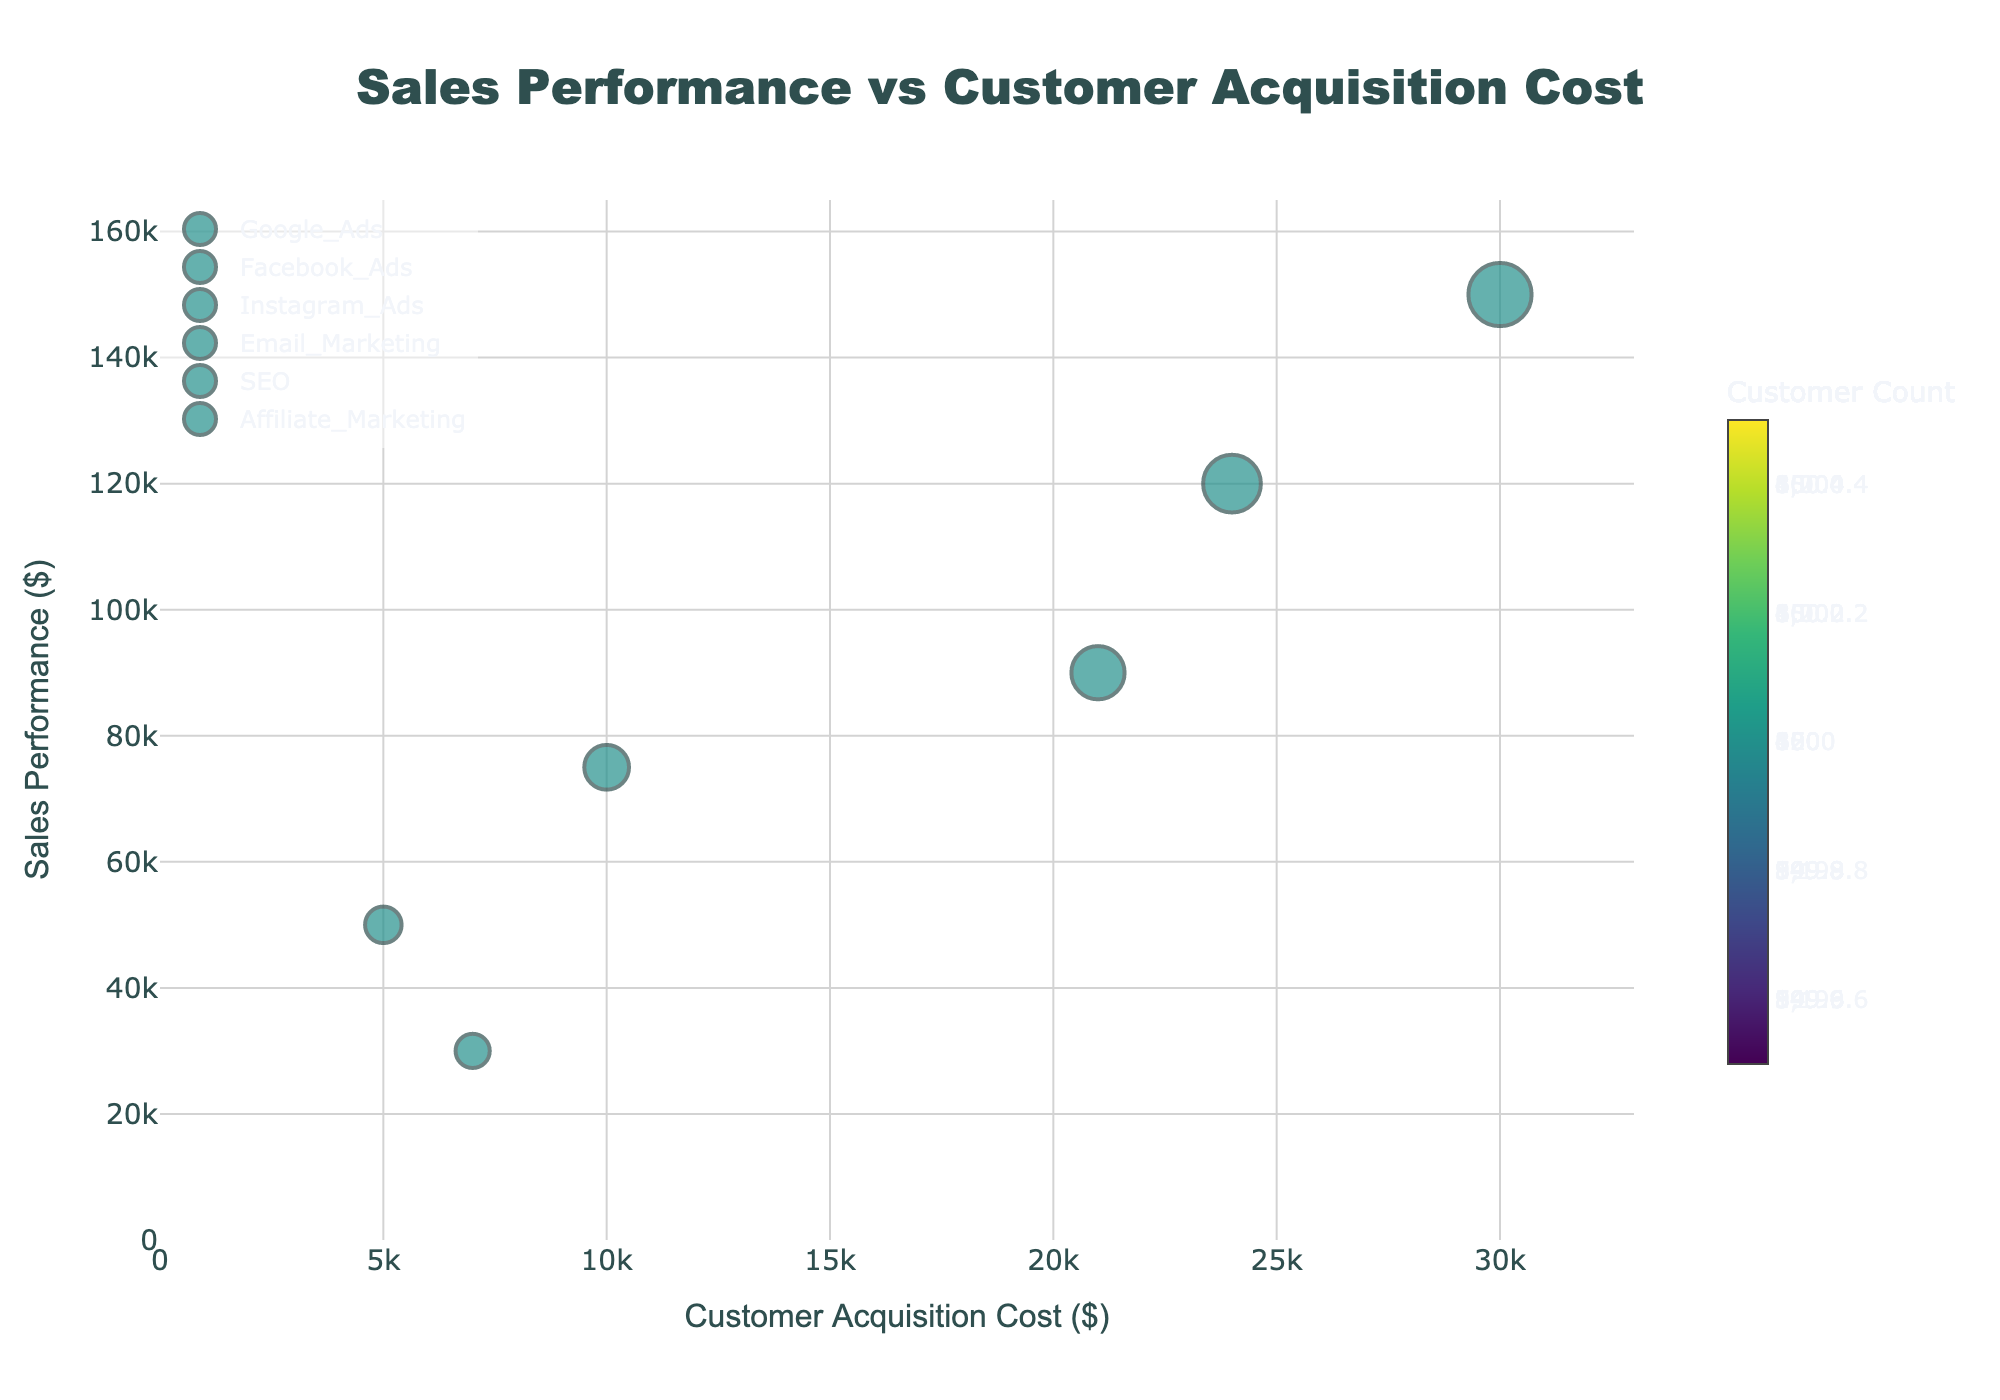How many marketing channels are plotted in the figure? The figure shows one bubble per marketing channel. Count the unique marketing channels (one bubble per channel) represented in the figure.
Answer: 6 What is the title of the figure? Read the title text displayed at the top of the figure.
Answer: "Sales Performance vs Customer Acquisition Cost" Which marketing channel has the highest customer acquisition cost? Identify the bubble that is furthest to the right on the x-axis (Customer Acquisition Cost) and check its label.
Answer: Google Ads Which marketing channel has the lowest sales performance? Identify the bubble that is lowest on the y-axis (Sales Performance) and check its label.
Answer: Affiliate Marketing How does the customer acquisition cost of Facebook Ads compare to Instagram Ads? Locate the bubbles representing Facebook Ads and Instagram Ads on the x-axis and compare their positions. Facebook Ads should be further right if its cost is higher.
Answer: Higher What is the total number of customers across all marketing channels? Sum the Customer_Count values for all channels: 1200 (Google Ads) + 1000 (Facebook Ads) + 850 (Instagram Ads) + 600 (Email Marketing) + 400 (SEO) + 350 (Affiliate Marketing).
Answer: 4400 What is the average sales performance for all marketing channels? Sum the Sales_Performance values for all channels and divide by the number of channels: (150000 + 120000 + 90000 + 75000 + 50000 + 30000) / 6.
Answer: $85,833 Which marketing channel has the highest number of customers? Identify the bubble with the largest size (diameter) and check the label.
Answer: Google Ads Which marketing channel shows the most cost-effective customer acquisition (lowest cost)? Identify the bubble that is furthest to the left on the x-axis (Customer Acquisition Cost) and check the label.
Answer: SEO Do higher customer acquisition costs generally lead to higher sales performance in the figure? Look for a trend or pattern in the bubbles' positioning along the x-axis and y-axis to see if higher costs align with higher sales.
Answer: Yes 